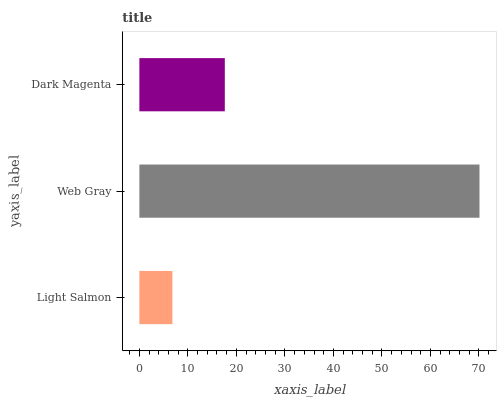Is Light Salmon the minimum?
Answer yes or no. Yes. Is Web Gray the maximum?
Answer yes or no. Yes. Is Dark Magenta the minimum?
Answer yes or no. No. Is Dark Magenta the maximum?
Answer yes or no. No. Is Web Gray greater than Dark Magenta?
Answer yes or no. Yes. Is Dark Magenta less than Web Gray?
Answer yes or no. Yes. Is Dark Magenta greater than Web Gray?
Answer yes or no. No. Is Web Gray less than Dark Magenta?
Answer yes or no. No. Is Dark Magenta the high median?
Answer yes or no. Yes. Is Dark Magenta the low median?
Answer yes or no. Yes. Is Web Gray the high median?
Answer yes or no. No. Is Web Gray the low median?
Answer yes or no. No. 